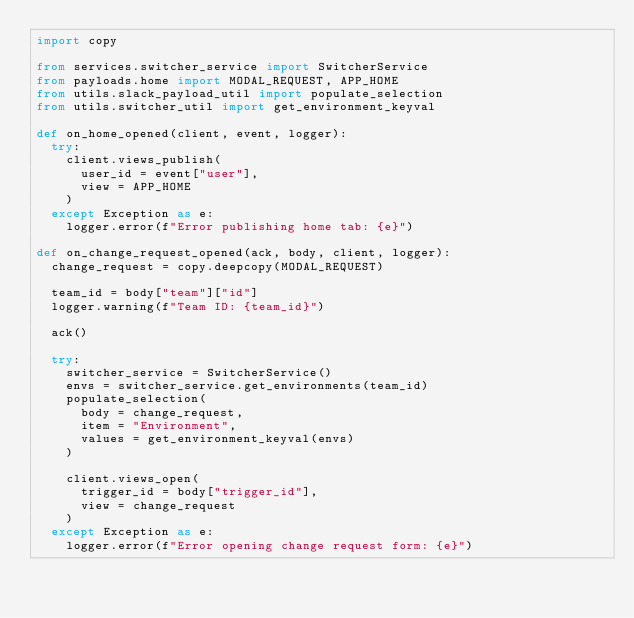<code> <loc_0><loc_0><loc_500><loc_500><_Python_>import copy

from services.switcher_service import SwitcherService
from payloads.home import MODAL_REQUEST, APP_HOME
from utils.slack_payload_util import populate_selection
from utils.switcher_util import get_environment_keyval

def on_home_opened(client, event, logger):
  try:
    client.views_publish(
      user_id = event["user"],
      view = APP_HOME
    )
  except Exception as e:
    logger.error(f"Error publishing home tab: {e}")

def on_change_request_opened(ack, body, client, logger):
  change_request = copy.deepcopy(MODAL_REQUEST)

  team_id = body["team"]["id"]
  logger.warning(f"Team ID: {team_id}")

  ack()

  try:
    switcher_service = SwitcherService()
    envs = switcher_service.get_environments(team_id)
    populate_selection(
      body = change_request,
      item = "Environment",
      values = get_environment_keyval(envs)
    )

    client.views_open(
      trigger_id = body["trigger_id"],
      view = change_request
    )
  except Exception as e:
    logger.error(f"Error opening change request form: {e}")</code> 